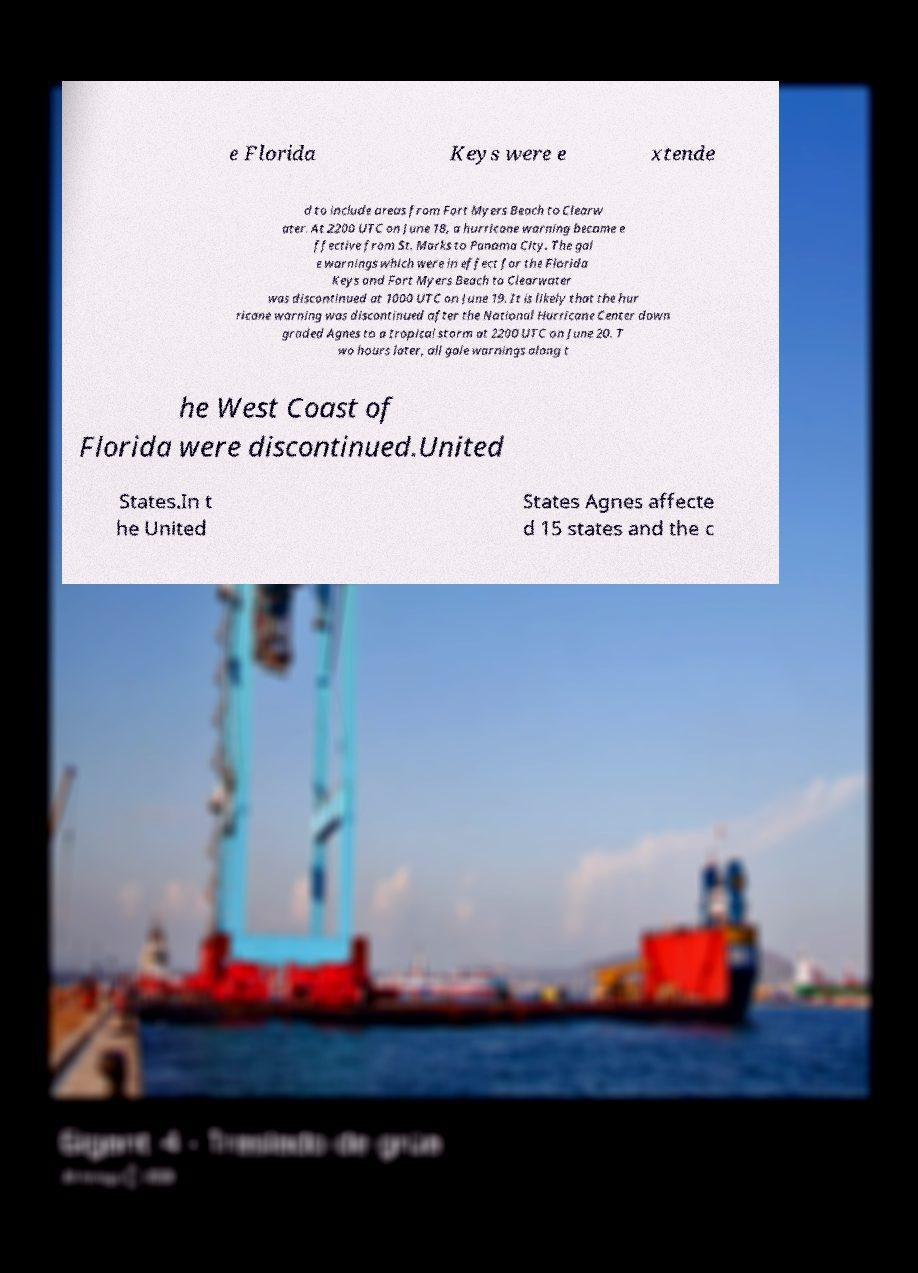Please identify and transcribe the text found in this image. e Florida Keys were e xtende d to include areas from Fort Myers Beach to Clearw ater. At 2200 UTC on June 18, a hurricane warning became e ffective from St. Marks to Panama City. The gal e warnings which were in effect for the Florida Keys and Fort Myers Beach to Clearwater was discontinued at 1000 UTC on June 19. It is likely that the hur ricane warning was discontinued after the National Hurricane Center down graded Agnes to a tropical storm at 2200 UTC on June 20. T wo hours later, all gale warnings along t he West Coast of Florida were discontinued.United States.In t he United States Agnes affecte d 15 states and the c 